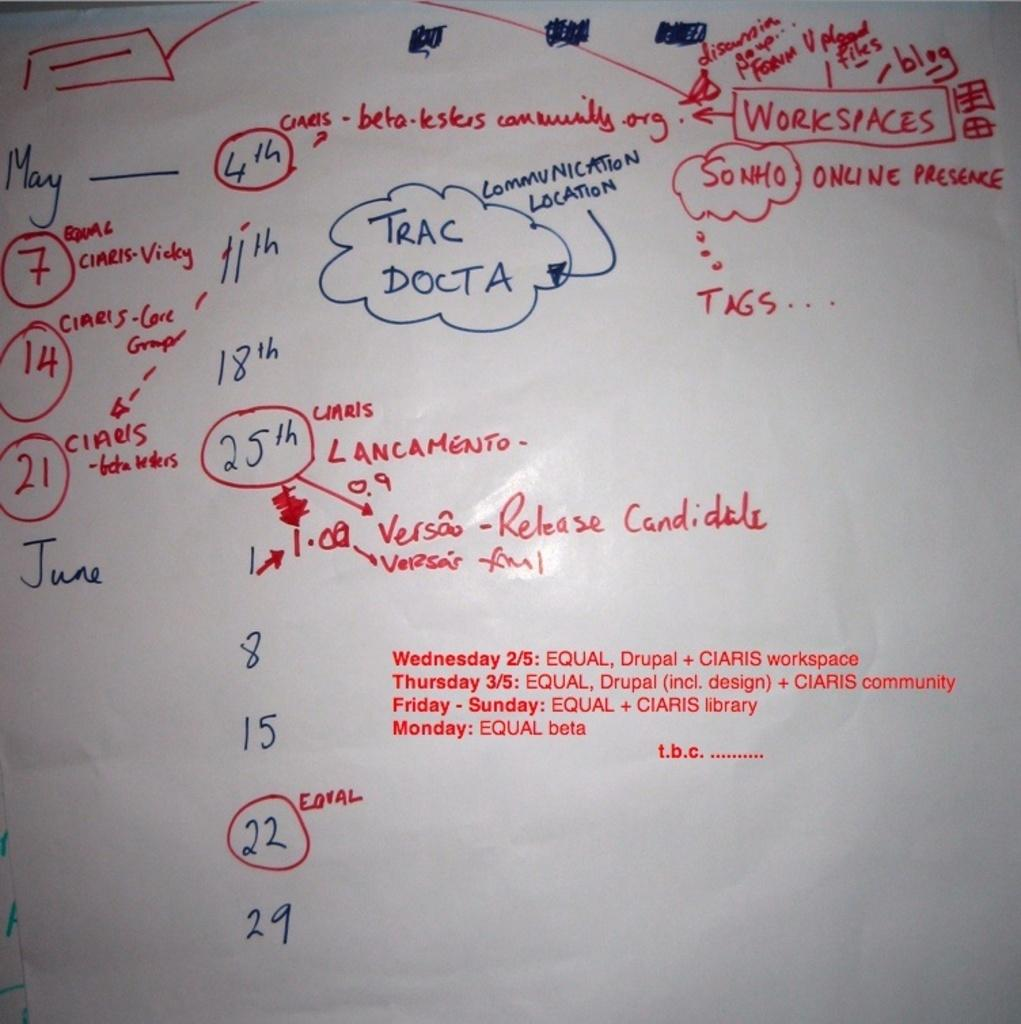What is the main subject of the image? The main subject of the image is text written on a white paper. Where is the text located on the paper? The text is in the middle of the image. What type of protest is taking place in the image? There is no protest present in the image; it only features text written on a white paper. What activity is the sink involved in within the image? There is no sink present in the image, so it cannot be involved in any activity. 